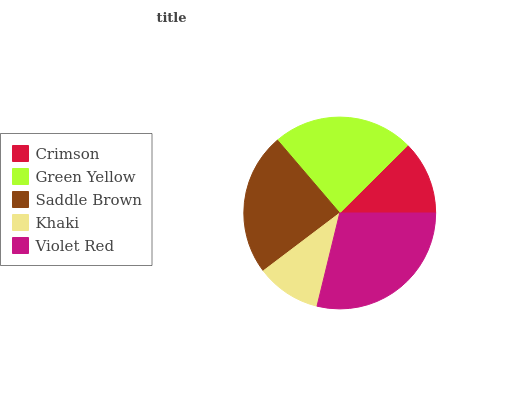Is Khaki the minimum?
Answer yes or no. Yes. Is Violet Red the maximum?
Answer yes or no. Yes. Is Green Yellow the minimum?
Answer yes or no. No. Is Green Yellow the maximum?
Answer yes or no. No. Is Green Yellow greater than Crimson?
Answer yes or no. Yes. Is Crimson less than Green Yellow?
Answer yes or no. Yes. Is Crimson greater than Green Yellow?
Answer yes or no. No. Is Green Yellow less than Crimson?
Answer yes or no. No. Is Green Yellow the high median?
Answer yes or no. Yes. Is Green Yellow the low median?
Answer yes or no. Yes. Is Khaki the high median?
Answer yes or no. No. Is Violet Red the low median?
Answer yes or no. No. 